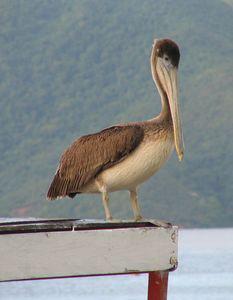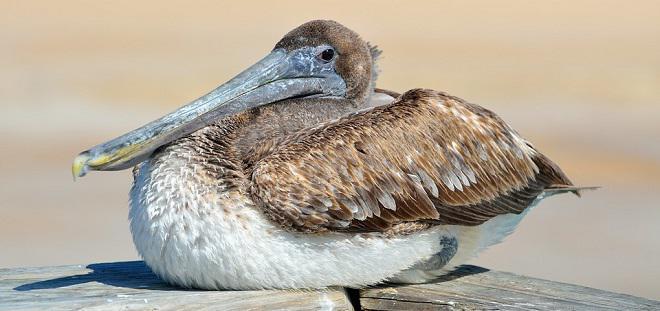The first image is the image on the left, the second image is the image on the right. Considering the images on both sides, is "One image shows one non-standing white pelican, and the other image shows multiple black and white pelicans." valid? Answer yes or no. No. The first image is the image on the left, the second image is the image on the right. Evaluate the accuracy of this statement regarding the images: "The left image contains no more than one bird.". Is it true? Answer yes or no. Yes. 